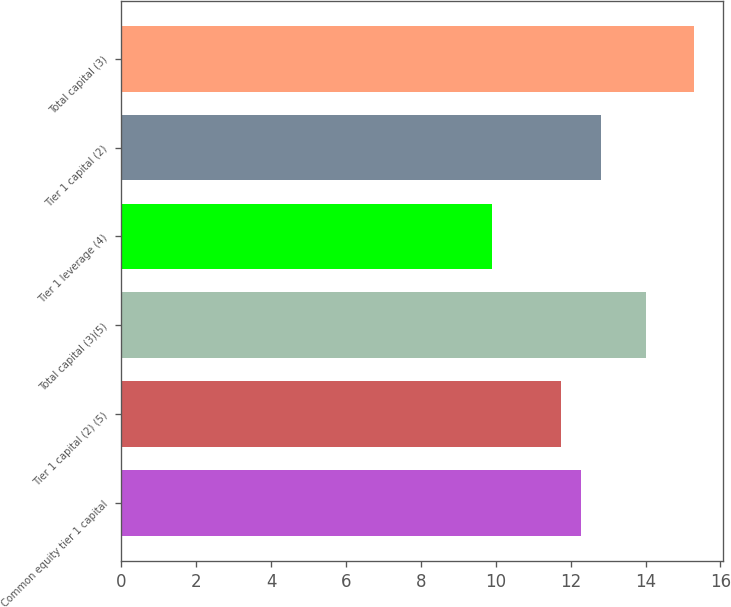<chart> <loc_0><loc_0><loc_500><loc_500><bar_chart><fcel>Common equity tier 1 capital<fcel>Tier 1 capital (2) (5)<fcel>Total capital (3)(5)<fcel>Tier 1 leverage (4)<fcel>Tier 1 capital (2)<fcel>Total capital (3)<nl><fcel>12.28<fcel>11.74<fcel>14<fcel>9.9<fcel>12.82<fcel>15.3<nl></chart> 